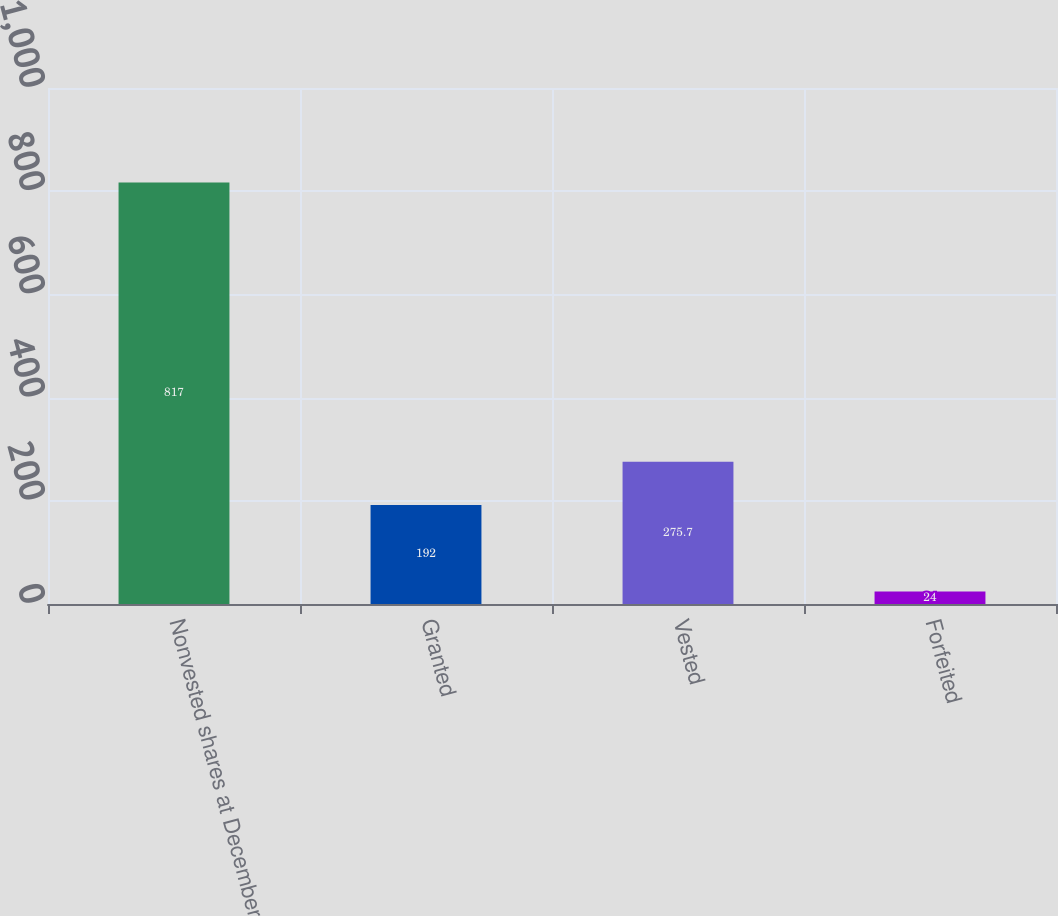<chart> <loc_0><loc_0><loc_500><loc_500><bar_chart><fcel>Nonvested shares at December<fcel>Granted<fcel>Vested<fcel>Forfeited<nl><fcel>817<fcel>192<fcel>275.7<fcel>24<nl></chart> 